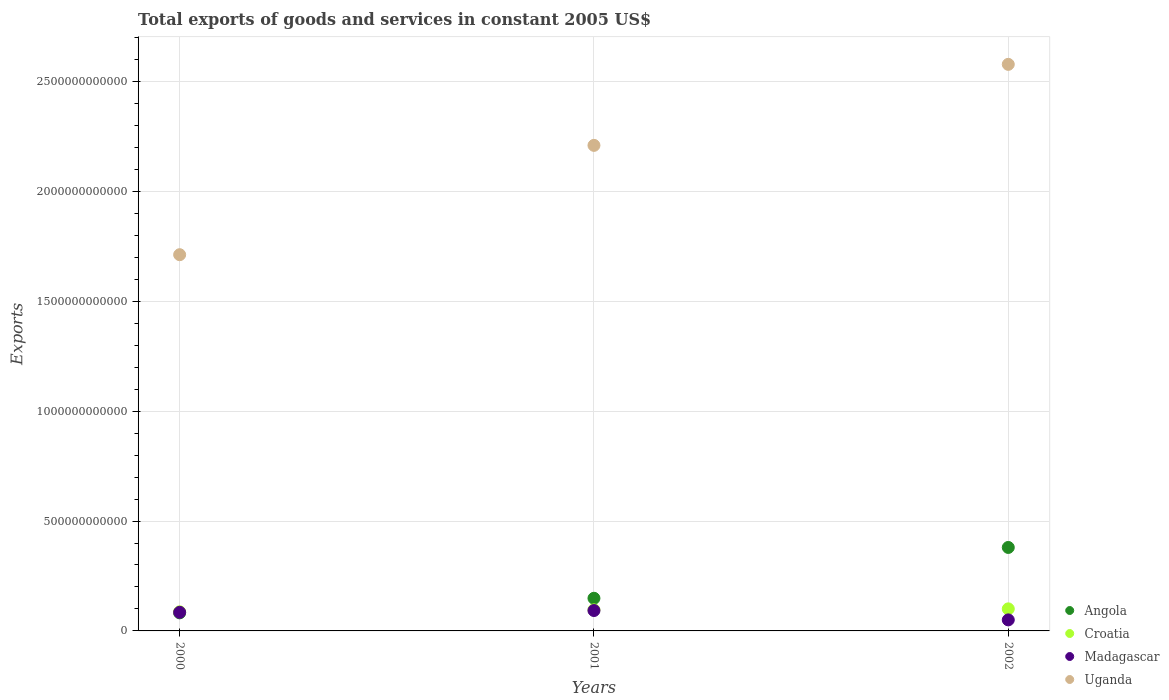How many different coloured dotlines are there?
Offer a very short reply. 4. Is the number of dotlines equal to the number of legend labels?
Provide a succinct answer. Yes. What is the total exports of goods and services in Uganda in 2000?
Provide a succinct answer. 1.71e+12. Across all years, what is the maximum total exports of goods and services in Angola?
Your response must be concise. 3.80e+11. Across all years, what is the minimum total exports of goods and services in Croatia?
Your answer should be very brief. 8.70e+1. What is the total total exports of goods and services in Angola in the graph?
Provide a succinct answer. 6.11e+11. What is the difference between the total exports of goods and services in Madagascar in 2000 and that in 2001?
Offer a very short reply. -8.12e+09. What is the difference between the total exports of goods and services in Uganda in 2002 and the total exports of goods and services in Croatia in 2001?
Your answer should be very brief. 2.48e+12. What is the average total exports of goods and services in Angola per year?
Provide a succinct answer. 2.04e+11. In the year 2002, what is the difference between the total exports of goods and services in Croatia and total exports of goods and services in Uganda?
Ensure brevity in your answer.  -2.48e+12. In how many years, is the total exports of goods and services in Madagascar greater than 2500000000000 US$?
Your answer should be very brief. 0. What is the ratio of the total exports of goods and services in Uganda in 2000 to that in 2001?
Provide a short and direct response. 0.77. Is the total exports of goods and services in Madagascar in 2000 less than that in 2001?
Your response must be concise. Yes. What is the difference between the highest and the second highest total exports of goods and services in Madagascar?
Keep it short and to the point. 8.12e+09. What is the difference between the highest and the lowest total exports of goods and services in Uganda?
Keep it short and to the point. 8.66e+11. In how many years, is the total exports of goods and services in Angola greater than the average total exports of goods and services in Angola taken over all years?
Your answer should be compact. 1. What is the difference between two consecutive major ticks on the Y-axis?
Keep it short and to the point. 5.00e+11. Are the values on the major ticks of Y-axis written in scientific E-notation?
Make the answer very short. No. Does the graph contain any zero values?
Your answer should be compact. No. How are the legend labels stacked?
Ensure brevity in your answer.  Vertical. What is the title of the graph?
Offer a terse response. Total exports of goods and services in constant 2005 US$. What is the label or title of the Y-axis?
Offer a terse response. Exports. What is the Exports in Angola in 2000?
Make the answer very short. 8.22e+1. What is the Exports in Croatia in 2000?
Provide a short and direct response. 8.70e+1. What is the Exports in Madagascar in 2000?
Your response must be concise. 8.47e+1. What is the Exports of Uganda in 2000?
Keep it short and to the point. 1.71e+12. What is the Exports in Angola in 2001?
Your answer should be compact. 1.49e+11. What is the Exports of Croatia in 2001?
Give a very brief answer. 9.58e+1. What is the Exports of Madagascar in 2001?
Make the answer very short. 9.28e+1. What is the Exports in Uganda in 2001?
Offer a very short reply. 2.21e+12. What is the Exports in Angola in 2002?
Your answer should be compact. 3.80e+11. What is the Exports in Croatia in 2002?
Your answer should be compact. 1.00e+11. What is the Exports in Madagascar in 2002?
Ensure brevity in your answer.  5.02e+1. What is the Exports of Uganda in 2002?
Your answer should be very brief. 2.58e+12. Across all years, what is the maximum Exports of Angola?
Offer a terse response. 3.80e+11. Across all years, what is the maximum Exports in Croatia?
Make the answer very short. 1.00e+11. Across all years, what is the maximum Exports of Madagascar?
Give a very brief answer. 9.28e+1. Across all years, what is the maximum Exports of Uganda?
Give a very brief answer. 2.58e+12. Across all years, what is the minimum Exports in Angola?
Make the answer very short. 8.22e+1. Across all years, what is the minimum Exports of Croatia?
Your answer should be very brief. 8.70e+1. Across all years, what is the minimum Exports of Madagascar?
Offer a terse response. 5.02e+1. Across all years, what is the minimum Exports in Uganda?
Your answer should be compact. 1.71e+12. What is the total Exports of Angola in the graph?
Your answer should be very brief. 6.11e+11. What is the total Exports of Croatia in the graph?
Make the answer very short. 2.83e+11. What is the total Exports of Madagascar in the graph?
Ensure brevity in your answer.  2.28e+11. What is the total Exports of Uganda in the graph?
Offer a terse response. 6.50e+12. What is the difference between the Exports in Angola in 2000 and that in 2001?
Give a very brief answer. -6.64e+1. What is the difference between the Exports of Croatia in 2000 and that in 2001?
Provide a short and direct response. -8.80e+09. What is the difference between the Exports of Madagascar in 2000 and that in 2001?
Provide a succinct answer. -8.12e+09. What is the difference between the Exports of Uganda in 2000 and that in 2001?
Ensure brevity in your answer.  -4.98e+11. What is the difference between the Exports in Angola in 2000 and that in 2002?
Keep it short and to the point. -2.98e+11. What is the difference between the Exports of Croatia in 2000 and that in 2002?
Make the answer very short. -1.33e+1. What is the difference between the Exports in Madagascar in 2000 and that in 2002?
Your response must be concise. 3.45e+1. What is the difference between the Exports of Uganda in 2000 and that in 2002?
Your answer should be compact. -8.66e+11. What is the difference between the Exports of Angola in 2001 and that in 2002?
Give a very brief answer. -2.31e+11. What is the difference between the Exports in Croatia in 2001 and that in 2002?
Keep it short and to the point. -4.54e+09. What is the difference between the Exports of Madagascar in 2001 and that in 2002?
Your answer should be very brief. 4.26e+1. What is the difference between the Exports in Uganda in 2001 and that in 2002?
Your answer should be very brief. -3.69e+11. What is the difference between the Exports of Angola in 2000 and the Exports of Croatia in 2001?
Your answer should be very brief. -1.37e+1. What is the difference between the Exports in Angola in 2000 and the Exports in Madagascar in 2001?
Ensure brevity in your answer.  -1.06e+1. What is the difference between the Exports in Angola in 2000 and the Exports in Uganda in 2001?
Provide a succinct answer. -2.13e+12. What is the difference between the Exports of Croatia in 2000 and the Exports of Madagascar in 2001?
Provide a short and direct response. -5.74e+09. What is the difference between the Exports in Croatia in 2000 and the Exports in Uganda in 2001?
Your answer should be very brief. -2.12e+12. What is the difference between the Exports of Madagascar in 2000 and the Exports of Uganda in 2001?
Ensure brevity in your answer.  -2.12e+12. What is the difference between the Exports of Angola in 2000 and the Exports of Croatia in 2002?
Your response must be concise. -1.82e+1. What is the difference between the Exports of Angola in 2000 and the Exports of Madagascar in 2002?
Keep it short and to the point. 3.20e+1. What is the difference between the Exports of Angola in 2000 and the Exports of Uganda in 2002?
Give a very brief answer. -2.50e+12. What is the difference between the Exports in Croatia in 2000 and the Exports in Madagascar in 2002?
Keep it short and to the point. 3.68e+1. What is the difference between the Exports in Croatia in 2000 and the Exports in Uganda in 2002?
Offer a very short reply. -2.49e+12. What is the difference between the Exports in Madagascar in 2000 and the Exports in Uganda in 2002?
Provide a short and direct response. -2.49e+12. What is the difference between the Exports of Angola in 2001 and the Exports of Croatia in 2002?
Your answer should be compact. 4.82e+1. What is the difference between the Exports of Angola in 2001 and the Exports of Madagascar in 2002?
Keep it short and to the point. 9.84e+1. What is the difference between the Exports in Angola in 2001 and the Exports in Uganda in 2002?
Provide a succinct answer. -2.43e+12. What is the difference between the Exports of Croatia in 2001 and the Exports of Madagascar in 2002?
Give a very brief answer. 4.56e+1. What is the difference between the Exports of Croatia in 2001 and the Exports of Uganda in 2002?
Provide a short and direct response. -2.48e+12. What is the difference between the Exports of Madagascar in 2001 and the Exports of Uganda in 2002?
Offer a terse response. -2.49e+12. What is the average Exports of Angola per year?
Provide a short and direct response. 2.04e+11. What is the average Exports in Croatia per year?
Your answer should be very brief. 9.44e+1. What is the average Exports of Madagascar per year?
Offer a terse response. 7.59e+1. What is the average Exports in Uganda per year?
Ensure brevity in your answer.  2.17e+12. In the year 2000, what is the difference between the Exports of Angola and Exports of Croatia?
Offer a terse response. -4.88e+09. In the year 2000, what is the difference between the Exports of Angola and Exports of Madagascar?
Your answer should be very brief. -2.50e+09. In the year 2000, what is the difference between the Exports in Angola and Exports in Uganda?
Offer a terse response. -1.63e+12. In the year 2000, what is the difference between the Exports in Croatia and Exports in Madagascar?
Offer a terse response. 2.38e+09. In the year 2000, what is the difference between the Exports in Croatia and Exports in Uganda?
Offer a terse response. -1.63e+12. In the year 2000, what is the difference between the Exports of Madagascar and Exports of Uganda?
Ensure brevity in your answer.  -1.63e+12. In the year 2001, what is the difference between the Exports in Angola and Exports in Croatia?
Your answer should be compact. 5.28e+1. In the year 2001, what is the difference between the Exports in Angola and Exports in Madagascar?
Give a very brief answer. 5.58e+1. In the year 2001, what is the difference between the Exports in Angola and Exports in Uganda?
Offer a terse response. -2.06e+12. In the year 2001, what is the difference between the Exports of Croatia and Exports of Madagascar?
Provide a short and direct response. 3.07e+09. In the year 2001, what is the difference between the Exports in Croatia and Exports in Uganda?
Your response must be concise. -2.11e+12. In the year 2001, what is the difference between the Exports of Madagascar and Exports of Uganda?
Give a very brief answer. -2.12e+12. In the year 2002, what is the difference between the Exports of Angola and Exports of Croatia?
Ensure brevity in your answer.  2.79e+11. In the year 2002, what is the difference between the Exports in Angola and Exports in Madagascar?
Give a very brief answer. 3.30e+11. In the year 2002, what is the difference between the Exports of Angola and Exports of Uganda?
Offer a very short reply. -2.20e+12. In the year 2002, what is the difference between the Exports in Croatia and Exports in Madagascar?
Offer a very short reply. 5.02e+1. In the year 2002, what is the difference between the Exports of Croatia and Exports of Uganda?
Give a very brief answer. -2.48e+12. In the year 2002, what is the difference between the Exports of Madagascar and Exports of Uganda?
Provide a succinct answer. -2.53e+12. What is the ratio of the Exports in Angola in 2000 to that in 2001?
Make the answer very short. 0.55. What is the ratio of the Exports in Croatia in 2000 to that in 2001?
Your answer should be compact. 0.91. What is the ratio of the Exports in Madagascar in 2000 to that in 2001?
Give a very brief answer. 0.91. What is the ratio of the Exports in Uganda in 2000 to that in 2001?
Make the answer very short. 0.77. What is the ratio of the Exports in Angola in 2000 to that in 2002?
Make the answer very short. 0.22. What is the ratio of the Exports in Croatia in 2000 to that in 2002?
Provide a succinct answer. 0.87. What is the ratio of the Exports of Madagascar in 2000 to that in 2002?
Make the answer very short. 1.69. What is the ratio of the Exports in Uganda in 2000 to that in 2002?
Make the answer very short. 0.66. What is the ratio of the Exports in Angola in 2001 to that in 2002?
Ensure brevity in your answer.  0.39. What is the ratio of the Exports in Croatia in 2001 to that in 2002?
Offer a very short reply. 0.95. What is the ratio of the Exports of Madagascar in 2001 to that in 2002?
Keep it short and to the point. 1.85. What is the ratio of the Exports in Uganda in 2001 to that in 2002?
Offer a very short reply. 0.86. What is the difference between the highest and the second highest Exports in Angola?
Provide a short and direct response. 2.31e+11. What is the difference between the highest and the second highest Exports of Croatia?
Provide a short and direct response. 4.54e+09. What is the difference between the highest and the second highest Exports of Madagascar?
Keep it short and to the point. 8.12e+09. What is the difference between the highest and the second highest Exports of Uganda?
Keep it short and to the point. 3.69e+11. What is the difference between the highest and the lowest Exports of Angola?
Your answer should be compact. 2.98e+11. What is the difference between the highest and the lowest Exports in Croatia?
Your response must be concise. 1.33e+1. What is the difference between the highest and the lowest Exports in Madagascar?
Your response must be concise. 4.26e+1. What is the difference between the highest and the lowest Exports in Uganda?
Give a very brief answer. 8.66e+11. 